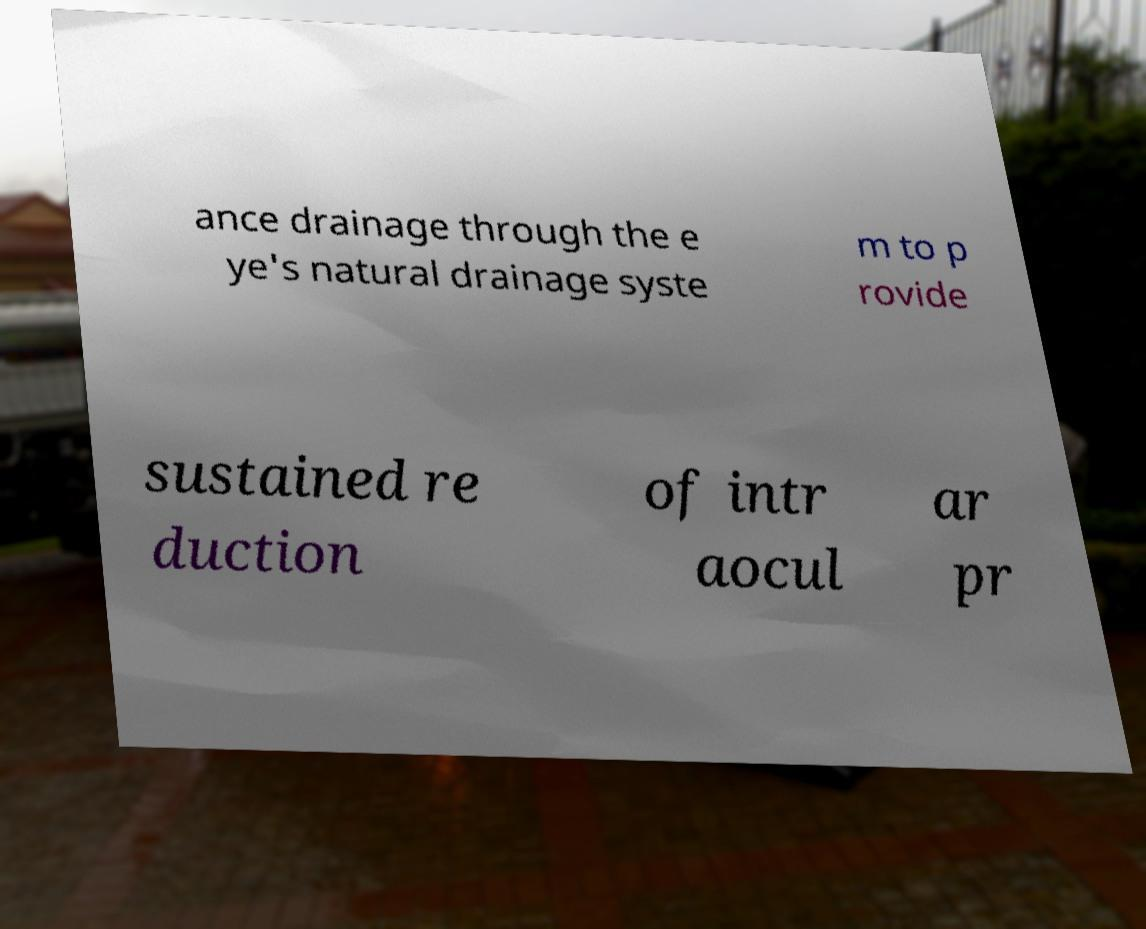What messages or text are displayed in this image? I need them in a readable, typed format. ance drainage through the e ye's natural drainage syste m to p rovide sustained re duction of intr aocul ar pr 